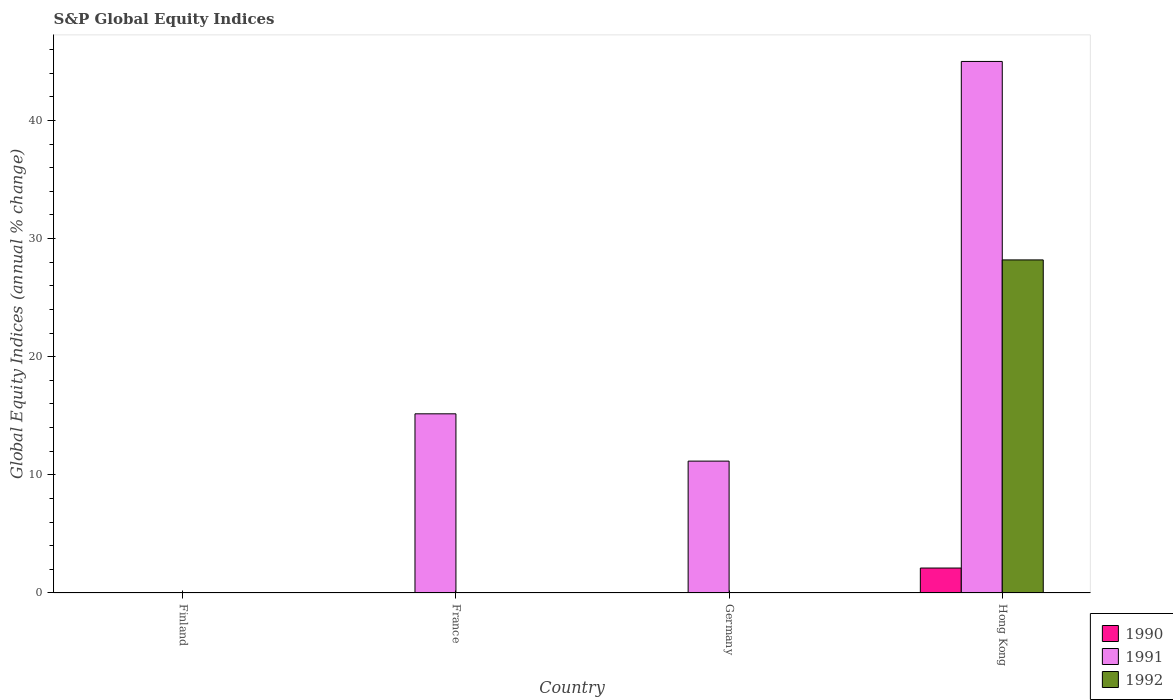How many different coloured bars are there?
Keep it short and to the point. 3. Are the number of bars on each tick of the X-axis equal?
Ensure brevity in your answer.  No. How many bars are there on the 1st tick from the right?
Ensure brevity in your answer.  3. In how many cases, is the number of bars for a given country not equal to the number of legend labels?
Give a very brief answer. 3. What is the global equity indices in 1991 in France?
Provide a succinct answer. 15.17. Across all countries, what is the maximum global equity indices in 1990?
Your response must be concise. 2.11. In which country was the global equity indices in 1991 maximum?
Provide a succinct answer. Hong Kong. What is the total global equity indices in 1992 in the graph?
Offer a terse response. 28.19. What is the difference between the global equity indices in 1991 in France and that in Germany?
Keep it short and to the point. 4. What is the difference between the global equity indices in 1991 in Germany and the global equity indices in 1992 in Hong Kong?
Your answer should be very brief. -17.03. What is the average global equity indices in 1990 per country?
Offer a terse response. 0.53. In how many countries, is the global equity indices in 1991 greater than 40 %?
Ensure brevity in your answer.  1. What is the ratio of the global equity indices in 1991 in France to that in Hong Kong?
Ensure brevity in your answer.  0.34. What is the difference between the highest and the second highest global equity indices in 1991?
Offer a very short reply. -33.83. What is the difference between the highest and the lowest global equity indices in 1990?
Offer a terse response. 2.11. In how many countries, is the global equity indices in 1992 greater than the average global equity indices in 1992 taken over all countries?
Your answer should be very brief. 1. Is the sum of the global equity indices in 1991 in Germany and Hong Kong greater than the maximum global equity indices in 1990 across all countries?
Make the answer very short. Yes. How many bars are there?
Your answer should be compact. 5. Are all the bars in the graph horizontal?
Offer a terse response. No. How many countries are there in the graph?
Your answer should be compact. 4. Are the values on the major ticks of Y-axis written in scientific E-notation?
Your answer should be very brief. No. Where does the legend appear in the graph?
Your answer should be compact. Bottom right. How many legend labels are there?
Ensure brevity in your answer.  3. How are the legend labels stacked?
Give a very brief answer. Vertical. What is the title of the graph?
Offer a very short reply. S&P Global Equity Indices. What is the label or title of the Y-axis?
Give a very brief answer. Global Equity Indices (annual % change). What is the Global Equity Indices (annual % change) of 1990 in Finland?
Your answer should be compact. 0. What is the Global Equity Indices (annual % change) in 1992 in Finland?
Offer a terse response. 0. What is the Global Equity Indices (annual % change) in 1991 in France?
Your answer should be compact. 15.17. What is the Global Equity Indices (annual % change) of 1992 in France?
Make the answer very short. 0. What is the Global Equity Indices (annual % change) of 1991 in Germany?
Offer a very short reply. 11.16. What is the Global Equity Indices (annual % change) in 1990 in Hong Kong?
Your answer should be very brief. 2.11. What is the Global Equity Indices (annual % change) of 1991 in Hong Kong?
Provide a succinct answer. 44.99. What is the Global Equity Indices (annual % change) of 1992 in Hong Kong?
Provide a short and direct response. 28.19. Across all countries, what is the maximum Global Equity Indices (annual % change) of 1990?
Ensure brevity in your answer.  2.11. Across all countries, what is the maximum Global Equity Indices (annual % change) in 1991?
Make the answer very short. 44.99. Across all countries, what is the maximum Global Equity Indices (annual % change) in 1992?
Offer a terse response. 28.19. Across all countries, what is the minimum Global Equity Indices (annual % change) of 1991?
Keep it short and to the point. 0. What is the total Global Equity Indices (annual % change) in 1990 in the graph?
Ensure brevity in your answer.  2.11. What is the total Global Equity Indices (annual % change) of 1991 in the graph?
Ensure brevity in your answer.  71.32. What is the total Global Equity Indices (annual % change) in 1992 in the graph?
Your response must be concise. 28.19. What is the difference between the Global Equity Indices (annual % change) of 1991 in France and that in Germany?
Give a very brief answer. 4. What is the difference between the Global Equity Indices (annual % change) in 1991 in France and that in Hong Kong?
Keep it short and to the point. -29.83. What is the difference between the Global Equity Indices (annual % change) of 1991 in Germany and that in Hong Kong?
Offer a terse response. -33.83. What is the difference between the Global Equity Indices (annual % change) of 1991 in France and the Global Equity Indices (annual % change) of 1992 in Hong Kong?
Give a very brief answer. -13.03. What is the difference between the Global Equity Indices (annual % change) of 1991 in Germany and the Global Equity Indices (annual % change) of 1992 in Hong Kong?
Your answer should be compact. -17.03. What is the average Global Equity Indices (annual % change) of 1990 per country?
Keep it short and to the point. 0.53. What is the average Global Equity Indices (annual % change) of 1991 per country?
Your answer should be compact. 17.83. What is the average Global Equity Indices (annual % change) of 1992 per country?
Provide a succinct answer. 7.05. What is the difference between the Global Equity Indices (annual % change) of 1990 and Global Equity Indices (annual % change) of 1991 in Hong Kong?
Offer a very short reply. -42.88. What is the difference between the Global Equity Indices (annual % change) of 1990 and Global Equity Indices (annual % change) of 1992 in Hong Kong?
Keep it short and to the point. -26.08. What is the difference between the Global Equity Indices (annual % change) of 1991 and Global Equity Indices (annual % change) of 1992 in Hong Kong?
Offer a terse response. 16.8. What is the ratio of the Global Equity Indices (annual % change) of 1991 in France to that in Germany?
Your response must be concise. 1.36. What is the ratio of the Global Equity Indices (annual % change) in 1991 in France to that in Hong Kong?
Your response must be concise. 0.34. What is the ratio of the Global Equity Indices (annual % change) of 1991 in Germany to that in Hong Kong?
Provide a succinct answer. 0.25. What is the difference between the highest and the second highest Global Equity Indices (annual % change) in 1991?
Your answer should be very brief. 29.83. What is the difference between the highest and the lowest Global Equity Indices (annual % change) of 1990?
Make the answer very short. 2.11. What is the difference between the highest and the lowest Global Equity Indices (annual % change) in 1991?
Give a very brief answer. 44.99. What is the difference between the highest and the lowest Global Equity Indices (annual % change) of 1992?
Your response must be concise. 28.19. 